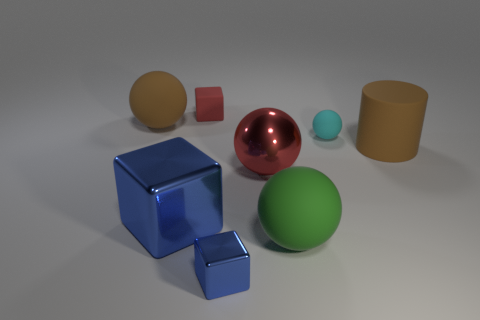There is a blue thing that is behind the large rubber sphere in front of the small rubber thing on the right side of the large green matte thing; what is its size?
Your answer should be very brief. Large. Is there a small red matte cube that is in front of the big matte sphere left of the tiny red block?
Provide a short and direct response. No. How many rubber spheres are in front of the big ball behind the big brown thing that is in front of the cyan sphere?
Keep it short and to the point. 2. There is a matte sphere that is both behind the large green thing and right of the small red rubber block; what is its color?
Ensure brevity in your answer.  Cyan. What number of other blocks are the same color as the big block?
Your answer should be compact. 1. How many cylinders are either small matte objects or red objects?
Keep it short and to the point. 0. There is a metal object that is the same size as the cyan matte ball; what is its color?
Keep it short and to the point. Blue. Is there a big matte sphere on the left side of the big cube that is in front of the tiny cube behind the small cyan thing?
Your answer should be very brief. Yes. The brown ball has what size?
Make the answer very short. Large. How many things are either large red things or big blue shiny blocks?
Offer a very short reply. 2. 